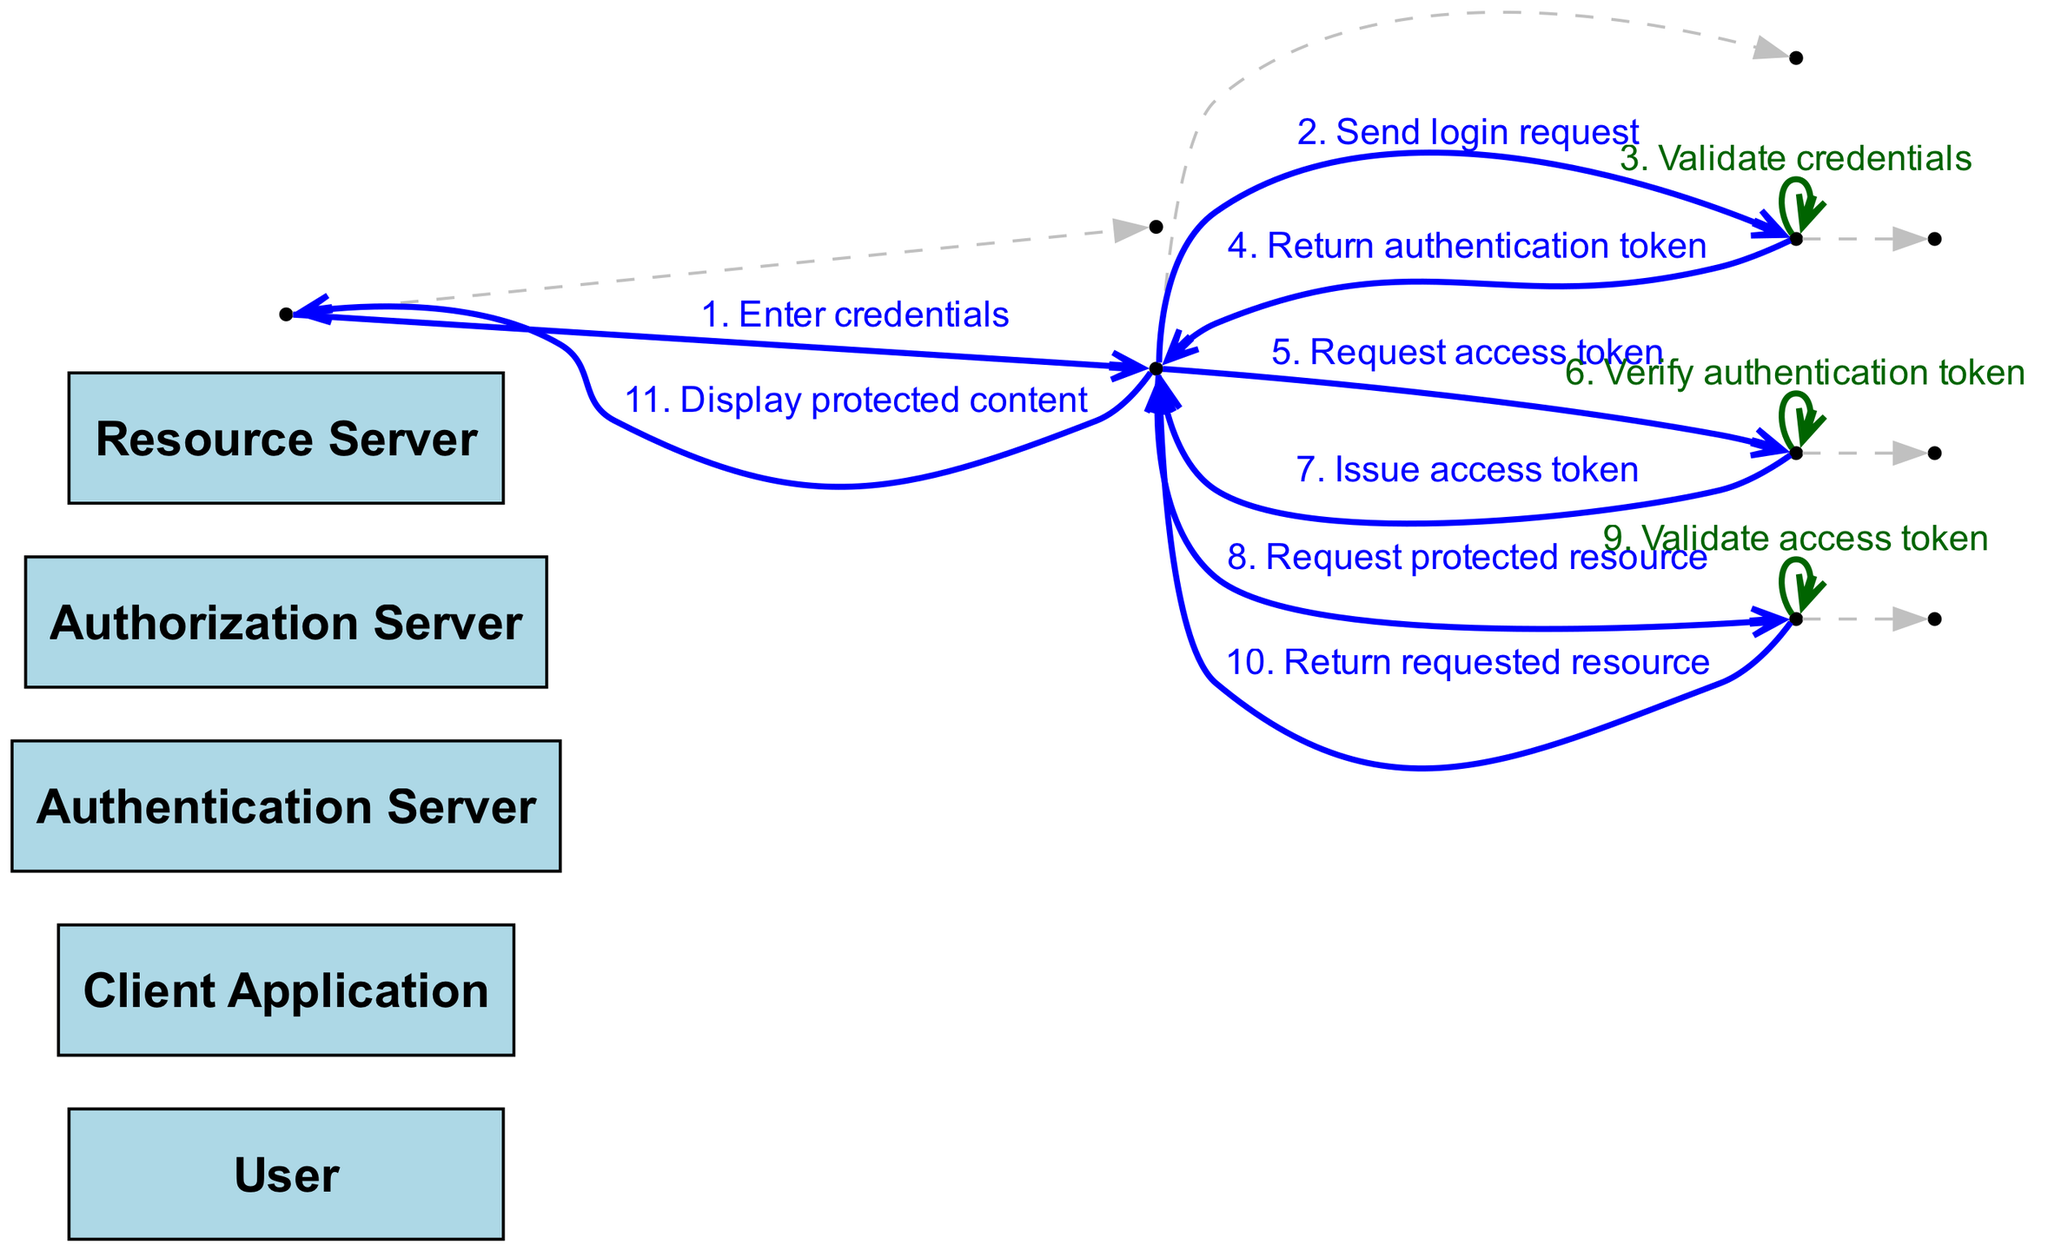What is the first action taken by the User? The User starts the authentication process by entering their credentials into the Client Application. This is the first step listed in the sequence.
Answer: Enter credentials How many actors are involved in the sequence diagram? The diagram lists five distinct actors: User, Client Application, Authentication Server, Authorization Server, and Resource Server. This counts as the total number of unique actors in the flow.
Answer: Five What does the Authentication Server return to the Client Application? After validating the credentials, the Authentication Server returns an authentication token to the Client Application, as indicated in the message exchanged.
Answer: Return authentication token Which action follows the issuance of the access token? After the Authorization Server issues the access token to the Client Application, the Client Application then requests a protected resource from the Resource Server. This sequential flow shows the progression from authorization to resource request.
Answer: Request protected resource What is the last action performed by the Client Application? The final action performed by the Client Application is to display the protected content to the User, as depicted in the last interaction of the sequence.
Answer: Display protected content What does the Resource Server do to the access token? The Resource Server validates the access token before returning the requested resource. This validation ensures that the access token is legitimate before granting access.
Answer: Validate access token How many messages are exchanged in total during the authentication and resource access process? The sequence diagram features eleven distinct messages exchanged between actors from start to finish, depicting the flow of the authentication and authorization process.
Answer: Eleven Which server verifies the authentication token? The Authorization Server is responsible for verifying the authentication token before it issues an access token to the Client Application. This ensures that the prior authentication was successful.
Answer: Authorization Server 